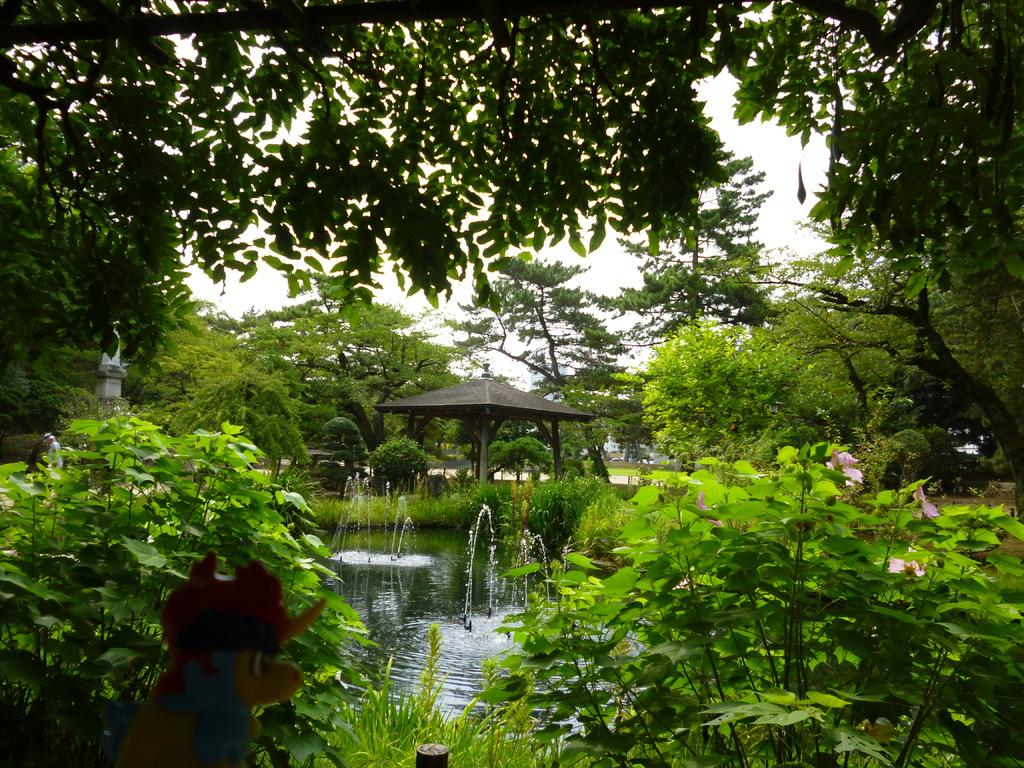What type of vegetation can be seen in the image? There are trees in the image. What is located at the bottom of the image? There is water at the bottom of the image. What object is present in the image for providing shade? There is an umbrella in the image. What is visible at the top of the image? The sky is visible at the top of the image. How many stars can be seen on the umbrella in the image? There are no stars visible on the umbrella in the image. What type of chalk is being used to draw on the trees in the image? There is no chalk or drawing activity present in the image. 